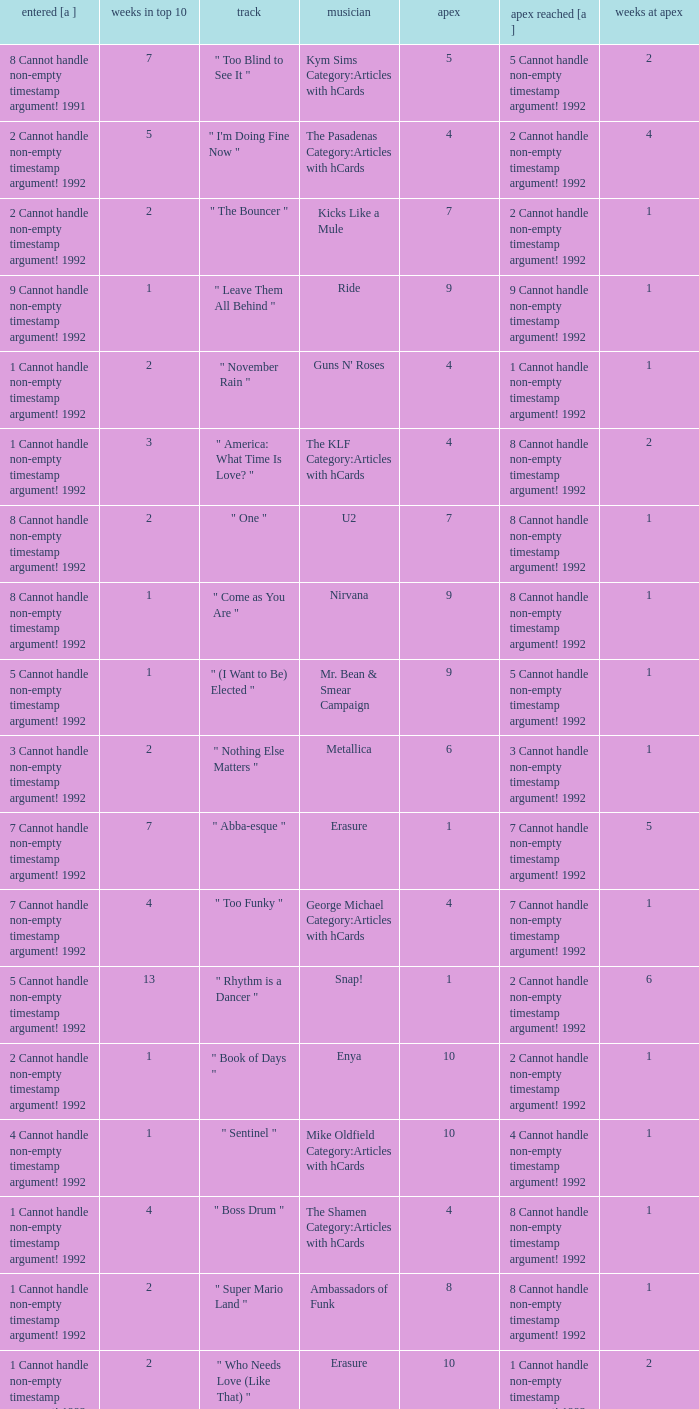If the highest rank achieved was 9, what was the number of weeks it spent in the top 10? 1.0. 